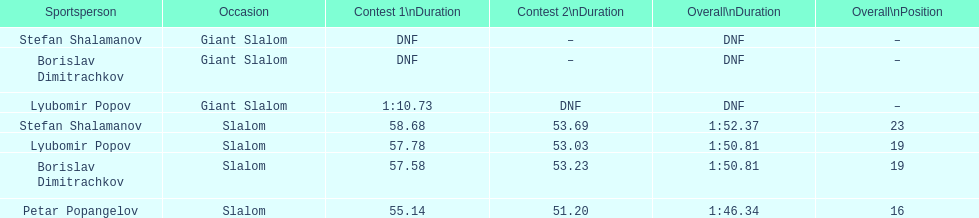Who was last in the slalom overall? Stefan Shalamanov. Would you be able to parse every entry in this table? {'header': ['Sportsperson', 'Occasion', 'Contest 1\\nDuration', 'Contest 2\\nDuration', 'Overall\\nDuration', 'Overall\\nPosition'], 'rows': [['Stefan Shalamanov', 'Giant Slalom', 'DNF', '–', 'DNF', '–'], ['Borislav Dimitrachkov', 'Giant Slalom', 'DNF', '–', 'DNF', '–'], ['Lyubomir Popov', 'Giant Slalom', '1:10.73', 'DNF', 'DNF', '–'], ['Stefan Shalamanov', 'Slalom', '58.68', '53.69', '1:52.37', '23'], ['Lyubomir Popov', 'Slalom', '57.78', '53.03', '1:50.81', '19'], ['Borislav Dimitrachkov', 'Slalom', '57.58', '53.23', '1:50.81', '19'], ['Petar Popangelov', 'Slalom', '55.14', '51.20', '1:46.34', '16']]} 